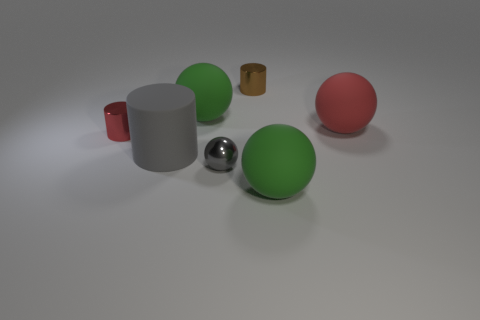What shape is the gray metallic object? sphere 